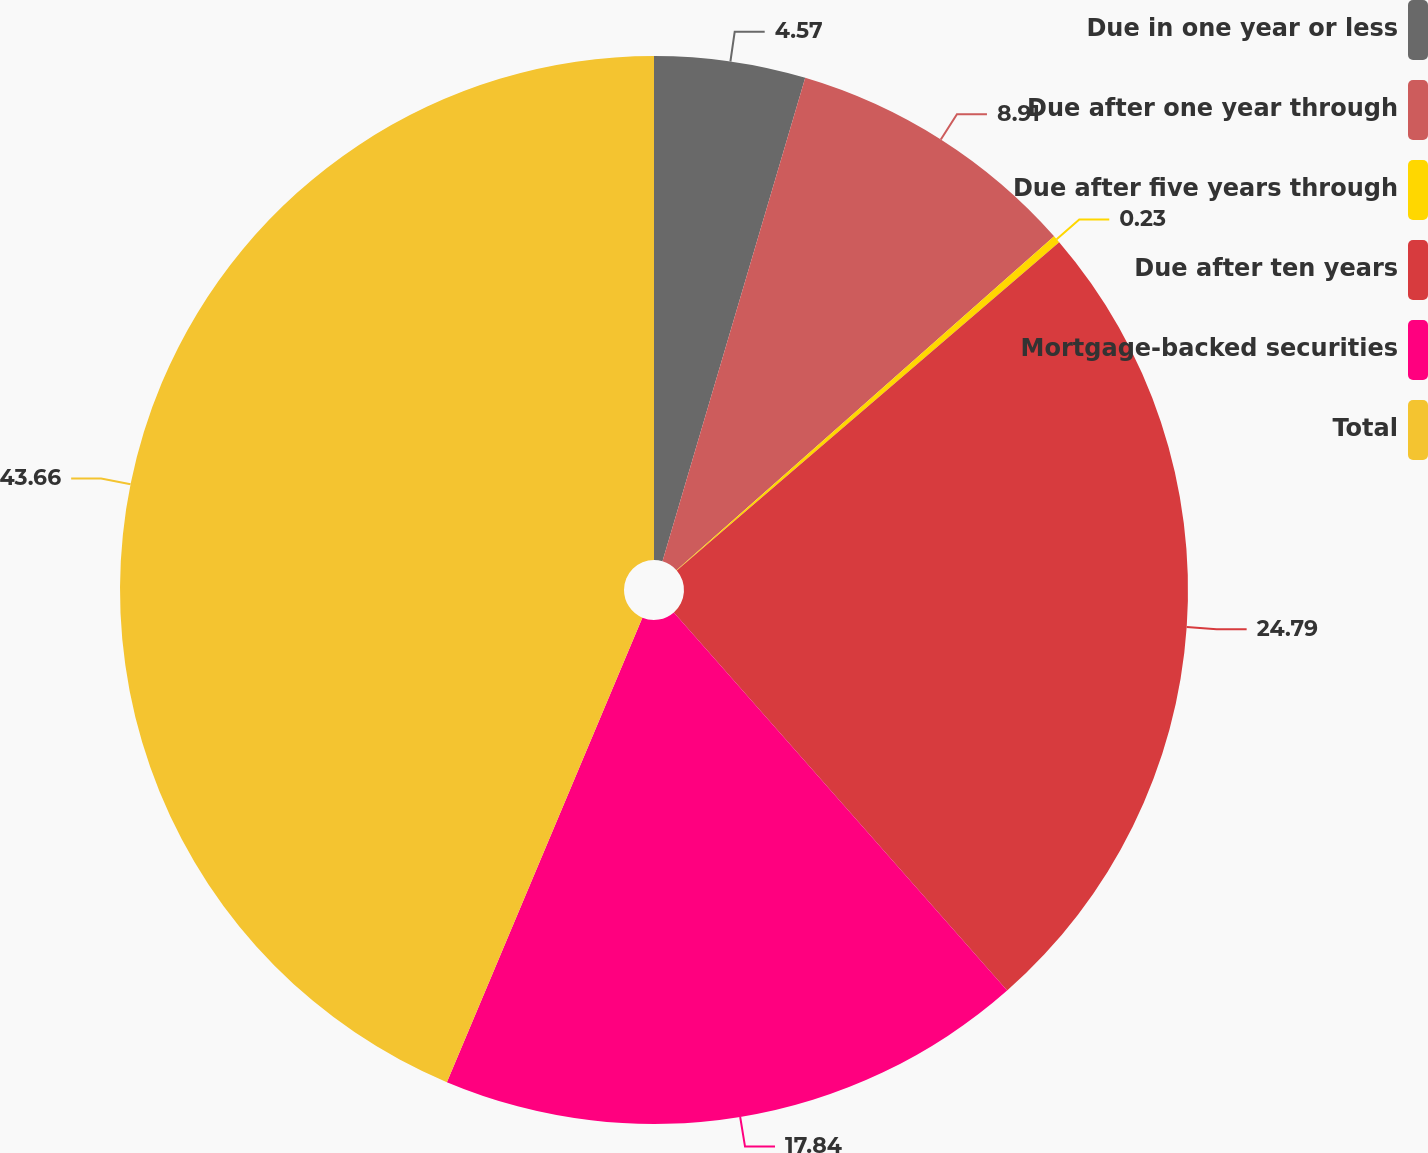<chart> <loc_0><loc_0><loc_500><loc_500><pie_chart><fcel>Due in one year or less<fcel>Due after one year through<fcel>Due after five years through<fcel>Due after ten years<fcel>Mortgage-backed securities<fcel>Total<nl><fcel>4.57%<fcel>8.91%<fcel>0.23%<fcel>24.79%<fcel>17.84%<fcel>43.66%<nl></chart> 